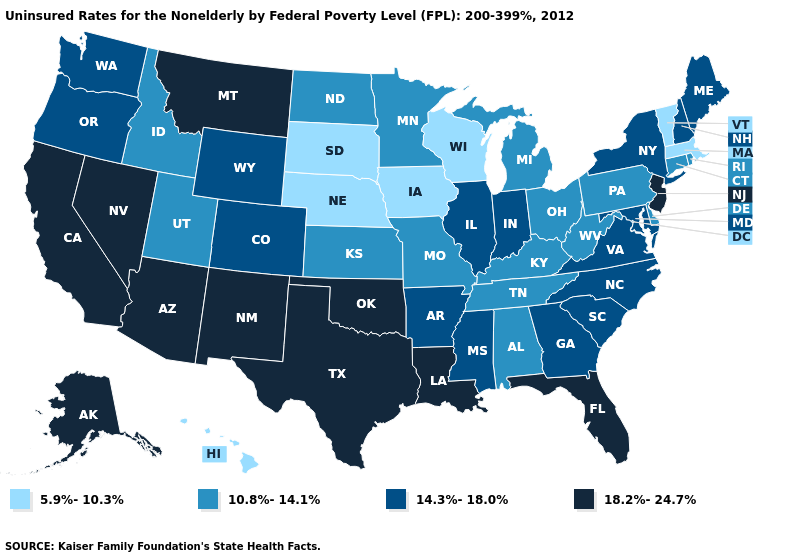What is the lowest value in the MidWest?
Concise answer only. 5.9%-10.3%. Name the states that have a value in the range 14.3%-18.0%?
Answer briefly. Arkansas, Colorado, Georgia, Illinois, Indiana, Maine, Maryland, Mississippi, New Hampshire, New York, North Carolina, Oregon, South Carolina, Virginia, Washington, Wyoming. Does Vermont have the lowest value in the Northeast?
Be succinct. Yes. What is the value of Michigan?
Answer briefly. 10.8%-14.1%. Name the states that have a value in the range 18.2%-24.7%?
Short answer required. Alaska, Arizona, California, Florida, Louisiana, Montana, Nevada, New Jersey, New Mexico, Oklahoma, Texas. Which states have the highest value in the USA?
Write a very short answer. Alaska, Arizona, California, Florida, Louisiana, Montana, Nevada, New Jersey, New Mexico, Oklahoma, Texas. What is the lowest value in the USA?
Write a very short answer. 5.9%-10.3%. What is the value of New Mexico?
Write a very short answer. 18.2%-24.7%. Is the legend a continuous bar?
Short answer required. No. Which states have the highest value in the USA?
Give a very brief answer. Alaska, Arizona, California, Florida, Louisiana, Montana, Nevada, New Jersey, New Mexico, Oklahoma, Texas. What is the value of Louisiana?
Give a very brief answer. 18.2%-24.7%. Name the states that have a value in the range 10.8%-14.1%?
Quick response, please. Alabama, Connecticut, Delaware, Idaho, Kansas, Kentucky, Michigan, Minnesota, Missouri, North Dakota, Ohio, Pennsylvania, Rhode Island, Tennessee, Utah, West Virginia. Does North Dakota have the lowest value in the USA?
Answer briefly. No. What is the lowest value in the USA?
Concise answer only. 5.9%-10.3%. 